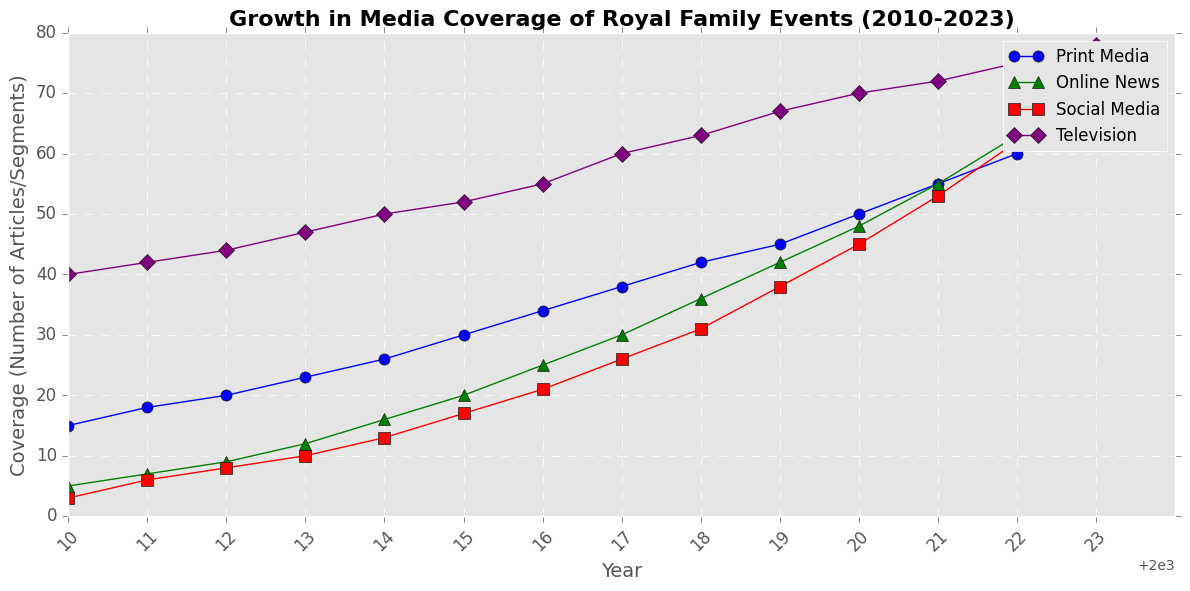Which platform showed the highest coverage in 2023? The highest coverage in 2023 can be identified by looking at the peak point among the lines for the year 2023. The purple line (Television) reaches the highest point at 78.
Answer: Television How did the coverage of Online News change from 2010 to 2023? To find the change in coverage, subtract the coverage in 2010 from the coverage in 2023 for Online News. The values are 5 (2010) and 70 (2023), so 70 - 5 = 65.
Answer: Increased by 65 In which year did Social Media coverage surpass Print Media coverage? By comparing the points where the red line (Social Media) crosses above the blue line (Print Media), we see that in 2023, Social Media coverage (70) surpasses Print Media (65).
Answer: 2023 Which platform had the steepest growth over the analyzed period? To determine the steepest growth, consider the slopes of the lines: calculate the difference in coverage from 2010 to 2023 for each platform. Social Media grew from 3 to 70 (67), which is the largest increase.
Answer: Social Media What is the average annual increase in Television coverage between 2010 and 2023? Calculate the change in Television coverage from 2010 to 2023 (78 - 40 = 38), then divide by the number of years (2023 - 2010 = 13). So, 38 / 13 ≈ 2.92.
Answer: Approximately 2.92 Was there any year where all platforms increased their coverage compared to the previous year? To identify such a year, note if all the lines have an increasing trend from one year to the next. Observing the figure, each year from 2010 to 2023 shows an increase in coverage across all platforms.
Answer: Yes, all years show increase When did Online News surpass Print Media in coverage? By inspecting the points where the green line (Online News) overtakes the blue line (Print Media), we see that in 2022, Online News (63) surpasses Print Media (60).
Answer: 2022 Which year shows the highest growth in Social Media coverage compared to the previous year? Calculate the yearly differences for Social Media and identify the year with the largest difference. From 2020 to 2021, the coverage increases by 53 - 45 = 8, which is the highest single-year growth.
Answer: 2021 Compare the growth trends of Print Media and Social Media from 2015 to 2023. Calculate the increase in coverage from 2015 to 2023 for Print Media (65 - 30 = 35) and Social Media (70 - 17 = 53). Print Media grew by 35 and Social Media by 53, showing that Social Media had a steeper growth trend.
Answer: Social Media had higher growth What is the median value for Television coverage over the years? Arrange the Television coverage values in order and find the middle value. The values are: 40, 42, 44, 47, 50, 52, 55, 60, 63, 67, 70, 72, 75, 78. The middle values are 55 and 60, so the median is (55 + 60) / 2 = 57.5.
Answer: 57.5 